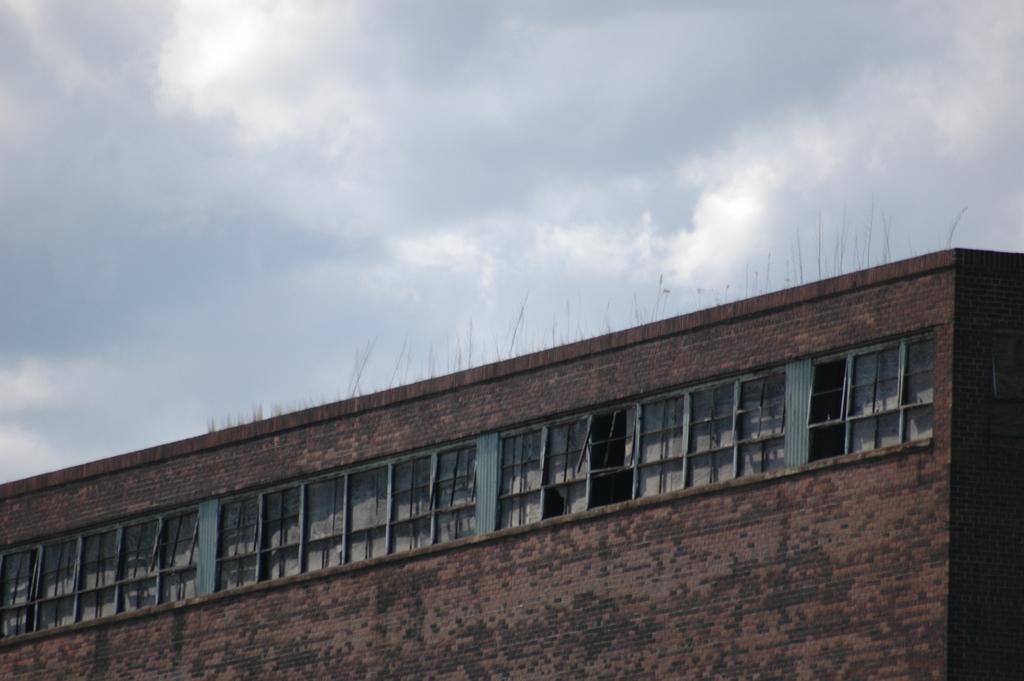Could you give a brief overview of what you see in this image? In this image I can see a building which is red and black in color made up of bricks and I can see few windows of the building. In the background I can see the sky. 